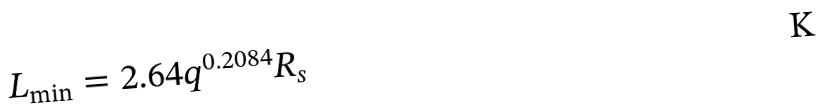Convert formula to latex. <formula><loc_0><loc_0><loc_500><loc_500>L _ { \min } = 2 . 6 4 q ^ { 0 . 2 0 8 4 } R _ { s }</formula> 